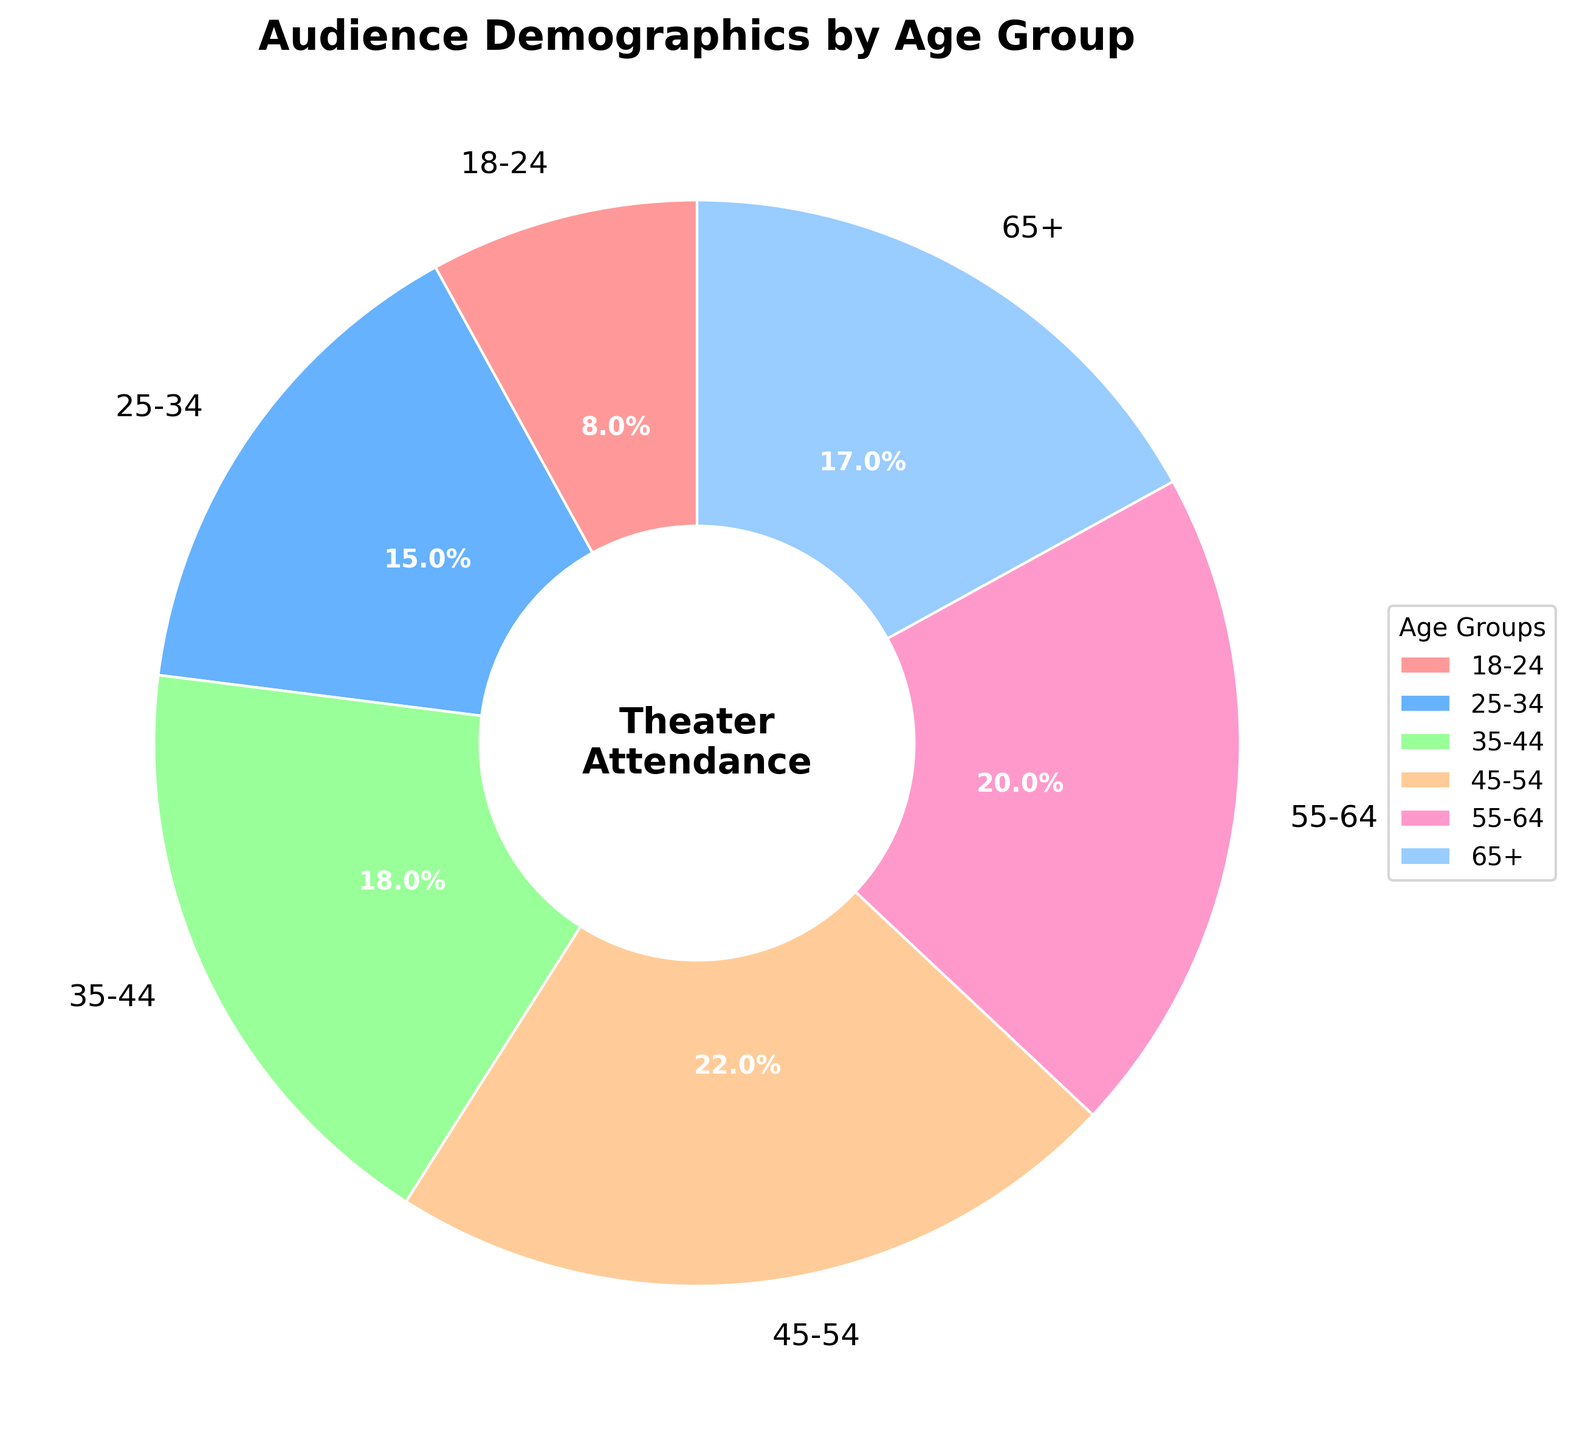What's the largest age group in theater attendance? The pie chart shows the percentages of different age groups at the theater. The largest wedge corresponds to the 45-54 age group, which is labeled as 22%.
Answer: 45-54 Which age group has the smallest representation in theater attendance? By examining the pie chart, the smallest wedge represents the 18-24 age group, which is labeled as 8%.
Answer: 18-24 What’s the combined percentage of theater attendance for people under 35 years old? To find the combined percentage for people under 35, we add the percentages for the 18-24 and 25-34 age groups: 8% + 15% = 23%.
Answer: 23% How does the attendance of the 55-64 age group compare to the 35-44 age group? By looking at the pie chart, the 55-64 age group has a 20% attendance, and the 35-44 age group has an 18% attendance, showing the 55-64 age group is 2% higher.
Answer: 2% higher Are there more attendees in the 65+ age group or the 18-24 age group? The pie chart shows that the 65+ age group has a 17% attendance, while the 18-24 age group has an 8% attendance, indicating the 65+ age group has more attendees.
Answer: 65+ Which two age groups combined make up the largest audience segment? Adding the percentages for various combinations, the 45-54 (22%) and 55-64 (20%) age groups sum up to 42%, the largest audience segment in the pie chart.
Answer: 45-54 and 55-64 How does the visual difference in wedge size between the 25-34 and 35-44 age groups represent their attendance difference? The 25-34 group has a 15% attendance, while the 35-44 group has 18%, making the wedge of the 35-44 group slightly larger by 3%. This visual difference indicates a 3% disparity in attendance.
Answer: 3% larger What percentage of the audience is 45 years old or older? Summing the percentages for the ages 45-54 (22%), 55-64 (20%), and 65+ (17%) gives the total percentage: 22% + 20% + 17% = 59%.
Answer: 59% How does the attendance for the group aged 55-64 visually compare to the group aged 18-24? The wedge for the 55-64 group (20%) is significantly larger than that for the 18-24 group (8%), which indicates that the 55-64 group has more than double the attendance of the 18-24 group.
Answer: More than double 